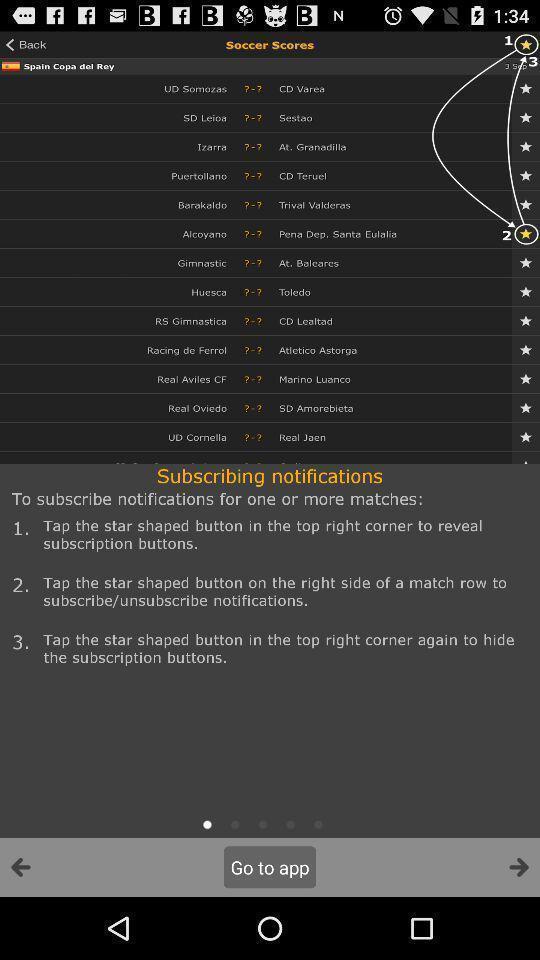Summarize the information in this screenshot. Window displaying a live score app. 